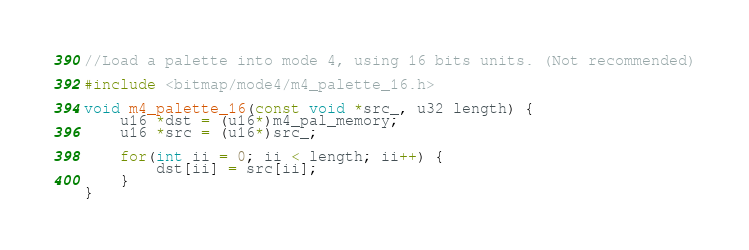<code> <loc_0><loc_0><loc_500><loc_500><_C_>//Load a palette into mode 4, using 16 bits units. (Not recommended)

#include <bitmap/mode4/m4_palette_16.h>

void m4_palette_16(const void *src_, u32 length) {
	u16 *dst = (u16*)m4_pal_memory;
	u16 *src = (u16*)src_;
	
	for(int ii = 0; ii < length; ii++) {
		dst[ii] = src[ii];
	}
}</code> 